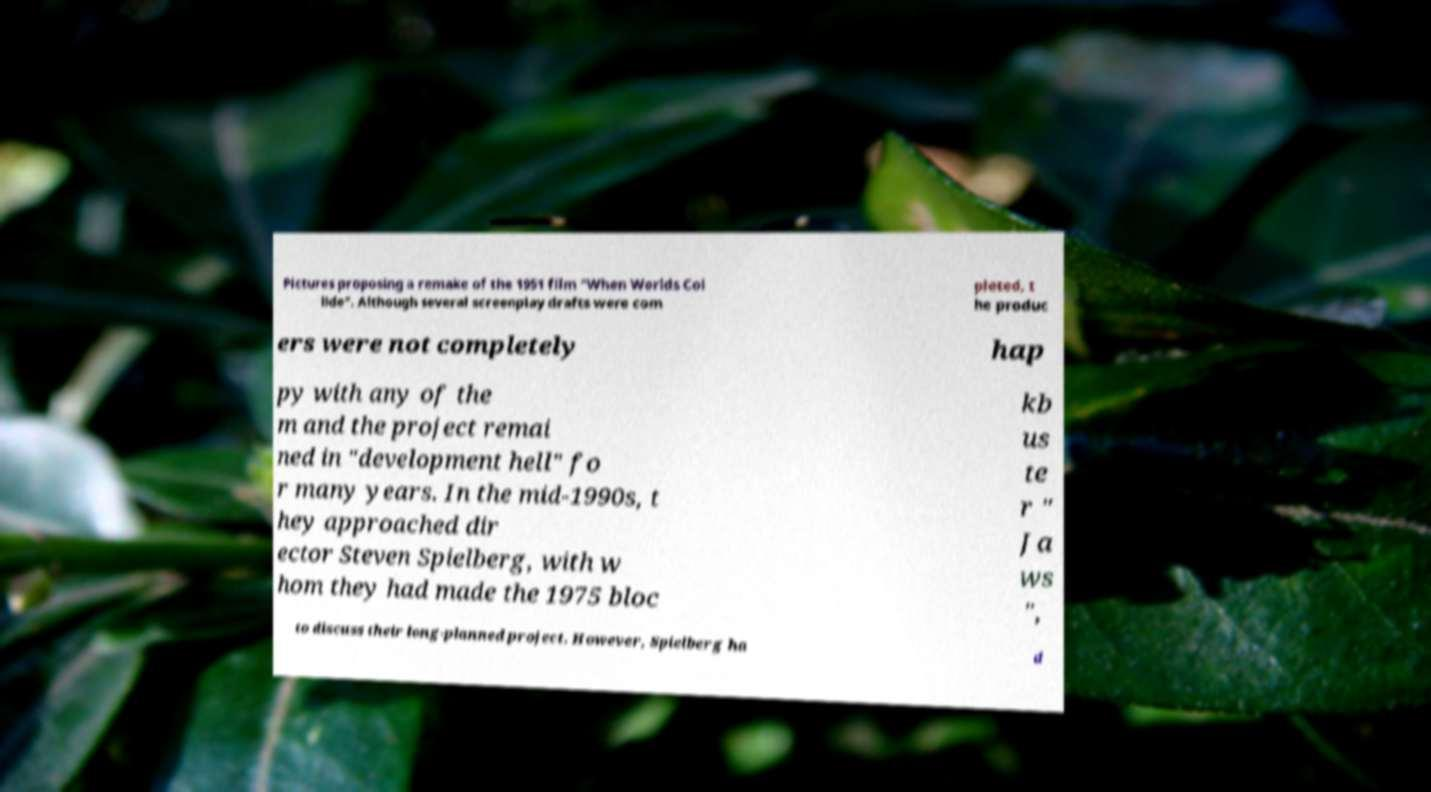There's text embedded in this image that I need extracted. Can you transcribe it verbatim? Pictures proposing a remake of the 1951 film "When Worlds Col lide". Although several screenplay drafts were com pleted, t he produc ers were not completely hap py with any of the m and the project remai ned in "development hell" fo r many years. In the mid-1990s, t hey approached dir ector Steven Spielberg, with w hom they had made the 1975 bloc kb us te r " Ja ws ", to discuss their long-planned project. However, Spielberg ha d 